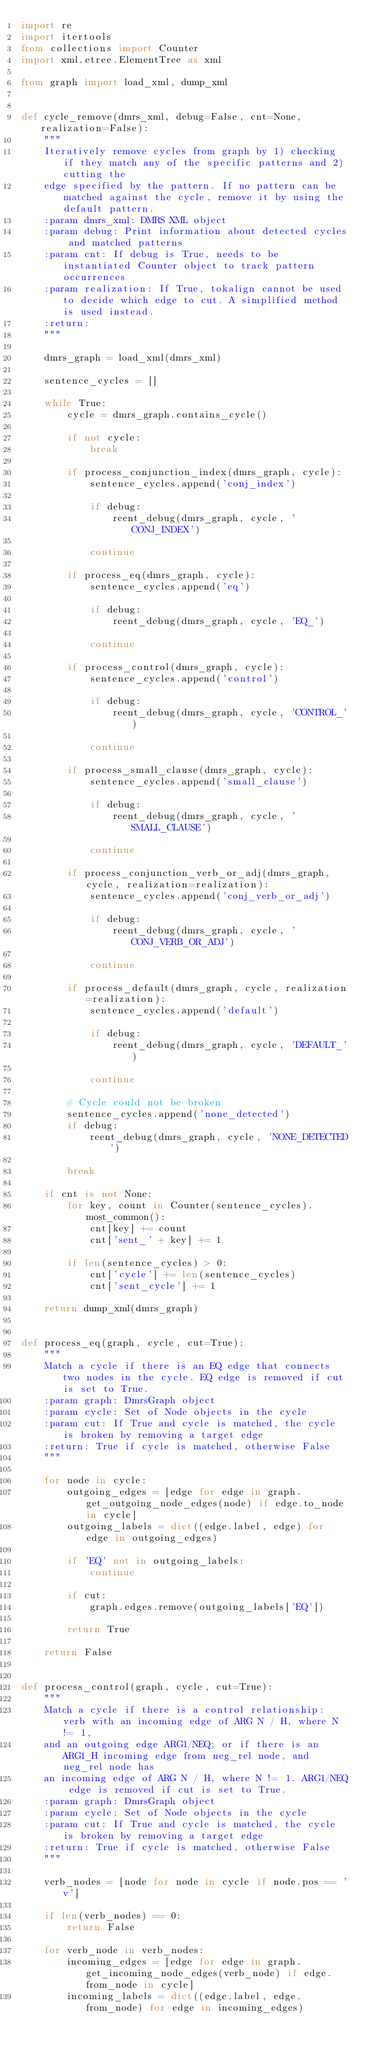Convert code to text. <code><loc_0><loc_0><loc_500><loc_500><_Python_>import re
import itertools
from collections import Counter
import xml.etree.ElementTree as xml

from graph import load_xml, dump_xml


def cycle_remove(dmrs_xml, debug=False, cnt=None, realization=False):
    """
    Iteratively remove cycles from graph by 1) checking if they match any of the specific patterns and 2) cutting the
    edge specified by the pattern. If no pattern can be matched against the cycle, remove it by using the default pattern.
    :param dmrs_xml: DMRS XML object
    :param debug: Print information about detected cycles and matched patterns
    :param cnt: If debug is True, needs to be instantiated Counter object to track pattern occurrences
    :param realization: If True, tokalign cannot be used to decide which edge to cut. A simplified method is used instead.
    :return:
    """

    dmrs_graph = load_xml(dmrs_xml)

    sentence_cycles = []

    while True:
        cycle = dmrs_graph.contains_cycle()

        if not cycle:
            break

        if process_conjunction_index(dmrs_graph, cycle):
            sentence_cycles.append('conj_index')

            if debug:
                reent_debug(dmrs_graph, cycle, 'CONJ_INDEX')

            continue

        if process_eq(dmrs_graph, cycle):
            sentence_cycles.append('eq')

            if debug:
                reent_debug(dmrs_graph, cycle, 'EQ_')

            continue

        if process_control(dmrs_graph, cycle):
            sentence_cycles.append('control')

            if debug:
                reent_debug(dmrs_graph, cycle, 'CONTROL_')

            continue

        if process_small_clause(dmrs_graph, cycle):
            sentence_cycles.append('small_clause')

            if debug:
                reent_debug(dmrs_graph, cycle, 'SMALL_CLAUSE')

            continue

        if process_conjunction_verb_or_adj(dmrs_graph, cycle, realization=realization):
            sentence_cycles.append('conj_verb_or_adj')

            if debug:
                reent_debug(dmrs_graph, cycle, 'CONJ_VERB_OR_ADJ')

            continue

        if process_default(dmrs_graph, cycle, realization=realization):
            sentence_cycles.append('default')

            if debug:
                reent_debug(dmrs_graph, cycle, 'DEFAULT_')

            continue

        # Cycle could not be broken
        sentence_cycles.append('none_detected')
        if debug:
            reent_debug(dmrs_graph, cycle, 'NONE_DETECTED')

        break

    if cnt is not None:
        for key, count in Counter(sentence_cycles).most_common():
            cnt[key] += count
            cnt['sent_' + key] += 1

        if len(sentence_cycles) > 0:
            cnt['cycle'] += len(sentence_cycles)
            cnt['sent_cycle'] += 1

    return dump_xml(dmrs_graph)


def process_eq(graph, cycle, cut=True):
    """
    Match a cycle if there is an EQ edge that connects two nodes in the cycle. EQ edge is removed if cut is set to True.
    :param graph: DmrsGraph object
    :param cycle: Set of Node objects in the cycle
    :param cut: If True and cycle is matched, the cycle is broken by removing a target edge
    :return: True if cycle is matched, otherwise False
    """

    for node in cycle:
        outgoing_edges = [edge for edge in graph.get_outgoing_node_edges(node) if edge.to_node in cycle]
        outgoing_labels = dict((edge.label, edge) for edge in outgoing_edges)

        if 'EQ' not in outgoing_labels:
            continue

        if cut:
            graph.edges.remove(outgoing_labels['EQ'])

        return True

    return False


def process_control(graph, cycle, cut=True):
    """
    Match a cycle if there is a control relationship: verb with an incoming edge of ARG N / H, where N != 1,
    and an outgoing edge ARG1/NEQ; or if there is an ARG1_H incoming edge from neg_rel node, and neg_rel node has
    an incoming edge of ARG N / H, where N != 1. ARG1/NEQ edge is removed if cut is set to True.
    :param graph: DmrsGraph object
    :param cycle: Set of Node objects in the cycle
    :param cut: If True and cycle is matched, the cycle is broken by removing a target edge
    :return: True if cycle is matched, otherwise False
    """

    verb_nodes = [node for node in cycle if node.pos == 'v']

    if len(verb_nodes) == 0:
        return False

    for verb_node in verb_nodes:
        incoming_edges = [edge for edge in graph.get_incoming_node_edges(verb_node) if edge.from_node in cycle]
        incoming_labels = dict((edge.label, edge.from_node) for edge in incoming_edges)</code> 